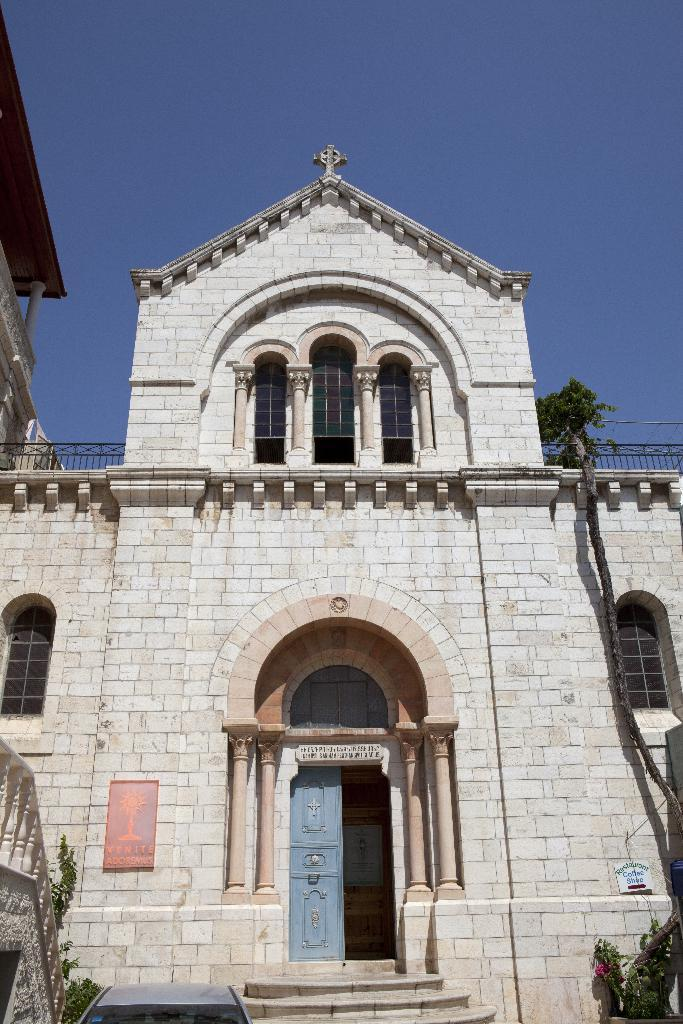What type of structure is present in the image? There is a building in the image. What can be seen in the background of the image? The sky is visible in the background of the image. What type of paste or glue is being used to hold the building together in the image? There is no mention of paste or glue being used to hold the building together in the image. 